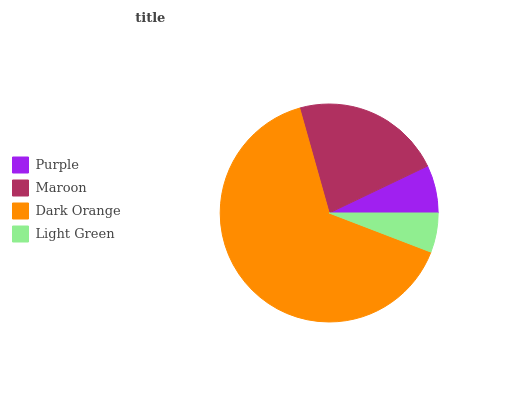Is Light Green the minimum?
Answer yes or no. Yes. Is Dark Orange the maximum?
Answer yes or no. Yes. Is Maroon the minimum?
Answer yes or no. No. Is Maroon the maximum?
Answer yes or no. No. Is Maroon greater than Purple?
Answer yes or no. Yes. Is Purple less than Maroon?
Answer yes or no. Yes. Is Purple greater than Maroon?
Answer yes or no. No. Is Maroon less than Purple?
Answer yes or no. No. Is Maroon the high median?
Answer yes or no. Yes. Is Purple the low median?
Answer yes or no. Yes. Is Dark Orange the high median?
Answer yes or no. No. Is Dark Orange the low median?
Answer yes or no. No. 